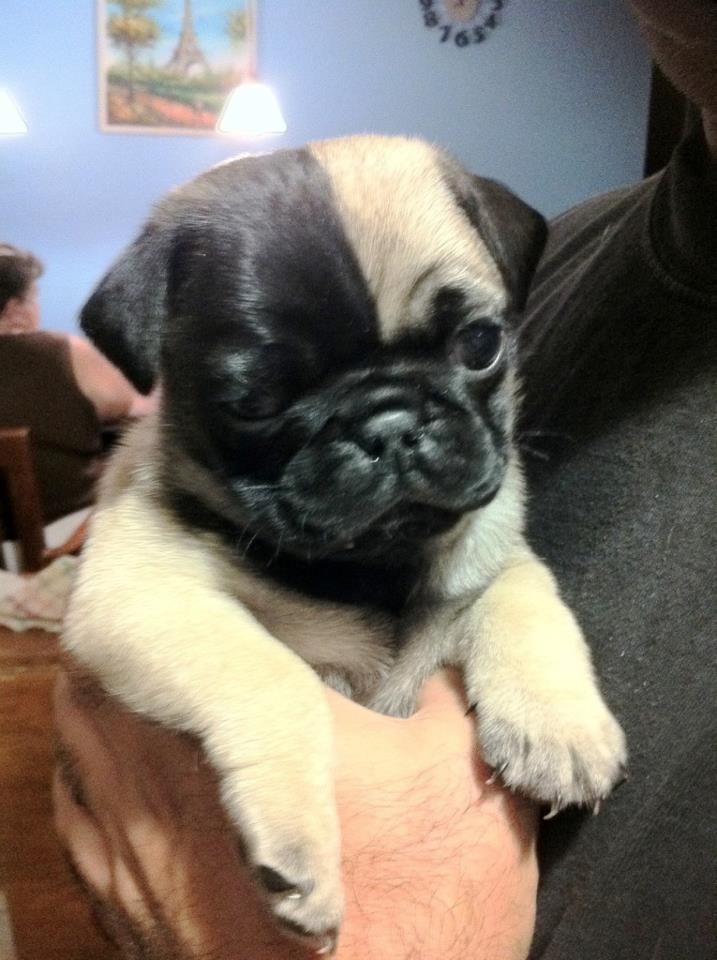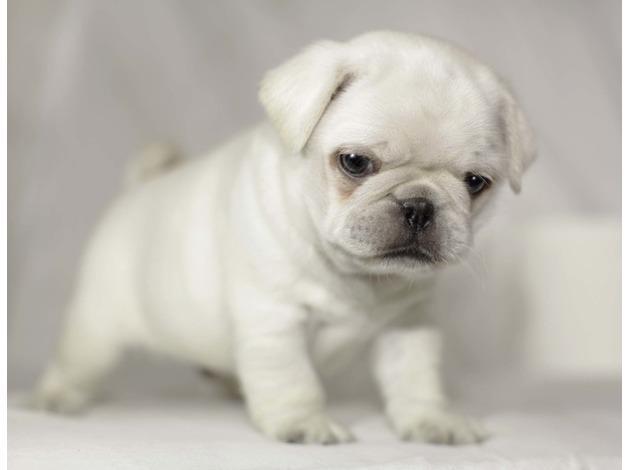The first image is the image on the left, the second image is the image on the right. Given the left and right images, does the statement "A human hand can be seen touching one puppy." hold true? Answer yes or no. Yes. The first image is the image on the left, the second image is the image on the right. Evaluate the accuracy of this statement regarding the images: "There are atleast 4 pugs total.". Is it true? Answer yes or no. No. 